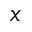<formula> <loc_0><loc_0><loc_500><loc_500>x</formula> 